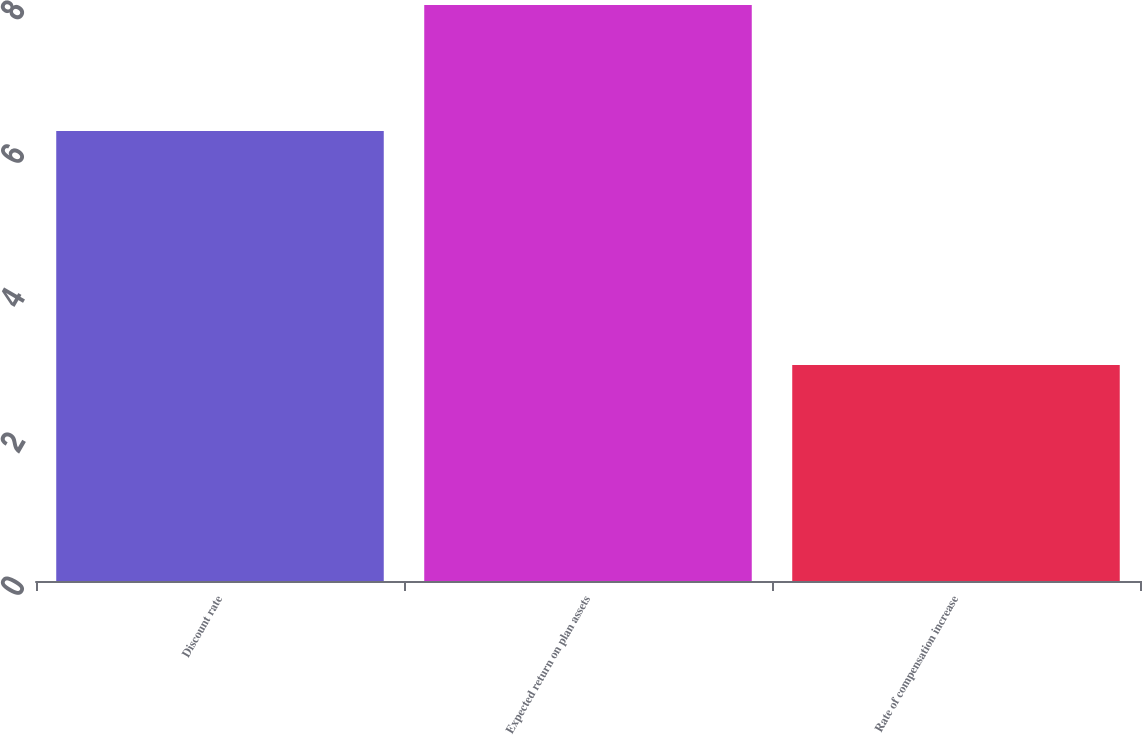<chart> <loc_0><loc_0><loc_500><loc_500><bar_chart><fcel>Discount rate<fcel>Expected return on plan assets<fcel>Rate of compensation increase<nl><fcel>6.25<fcel>8<fcel>3<nl></chart> 